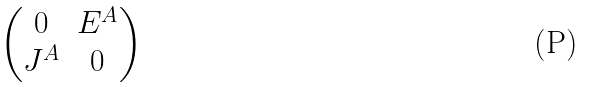Convert formula to latex. <formula><loc_0><loc_0><loc_500><loc_500>\begin{pmatrix} 0 & E ^ { A } \\ J ^ { A } & 0 \end{pmatrix}</formula> 